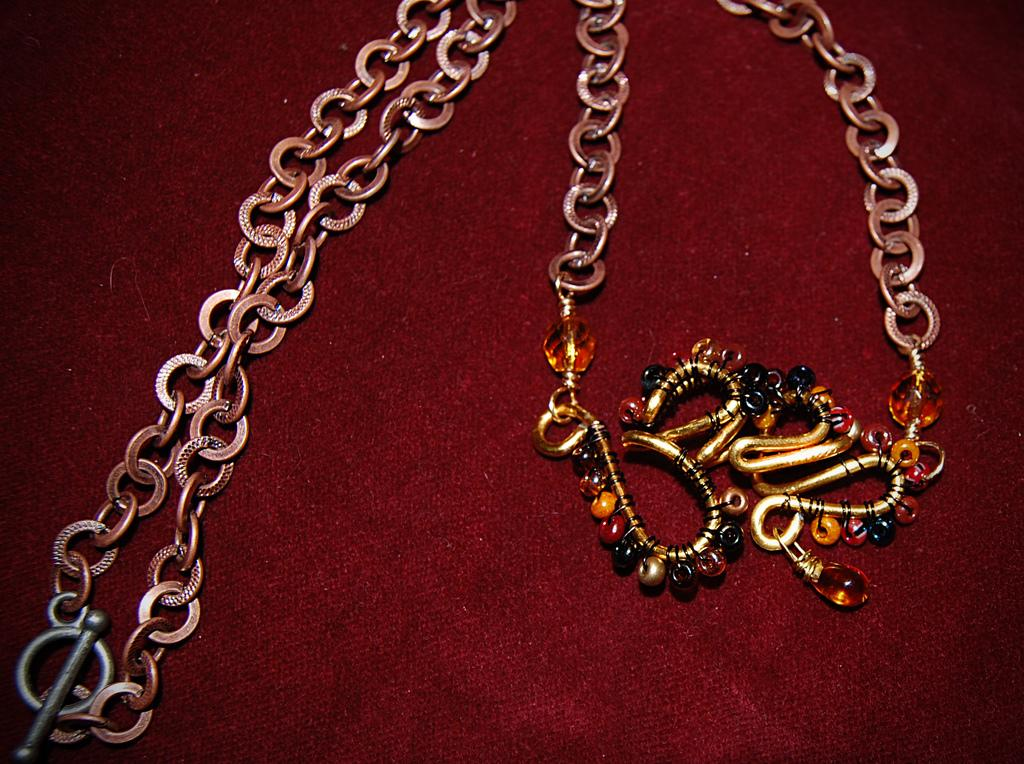What is the main object in the image? There is a chain in the image. Where is the chain located? The chain is on a platform. What type of lace can be seen on the train in the image? There is no train or lace present in the image; it only features a chain on a platform. What celestial bodies can be seen in the image? The image does not depict any space; it only shows a chain on a platform. 